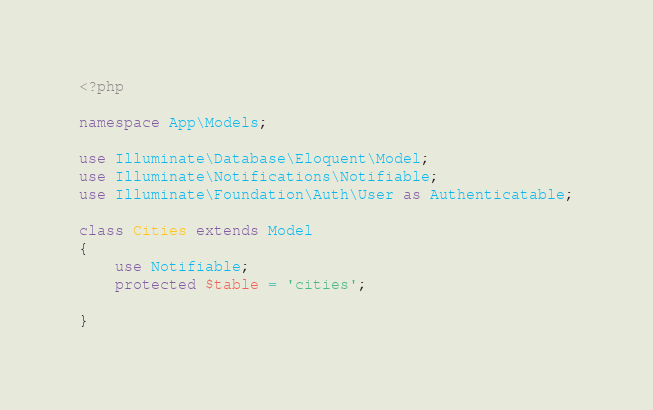<code> <loc_0><loc_0><loc_500><loc_500><_PHP_><?php

namespace App\Models;

use Illuminate\Database\Eloquent\Model;
use Illuminate\Notifications\Notifiable;
use Illuminate\Foundation\Auth\User as Authenticatable;

class Cities extends Model
{
    use Notifiable;
    protected $table = 'cities';
   
}
</code> 